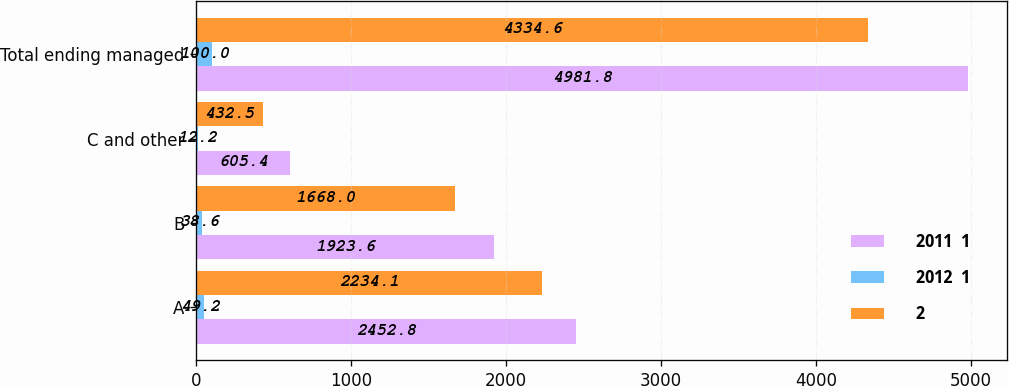<chart> <loc_0><loc_0><loc_500><loc_500><stacked_bar_chart><ecel><fcel>A<fcel>B<fcel>C and other<fcel>Total ending managed<nl><fcel>2011  1<fcel>2452.8<fcel>1923.6<fcel>605.4<fcel>4981.8<nl><fcel>2012  1<fcel>49.2<fcel>38.6<fcel>12.2<fcel>100<nl><fcel>2<fcel>2234.1<fcel>1668<fcel>432.5<fcel>4334.6<nl></chart> 